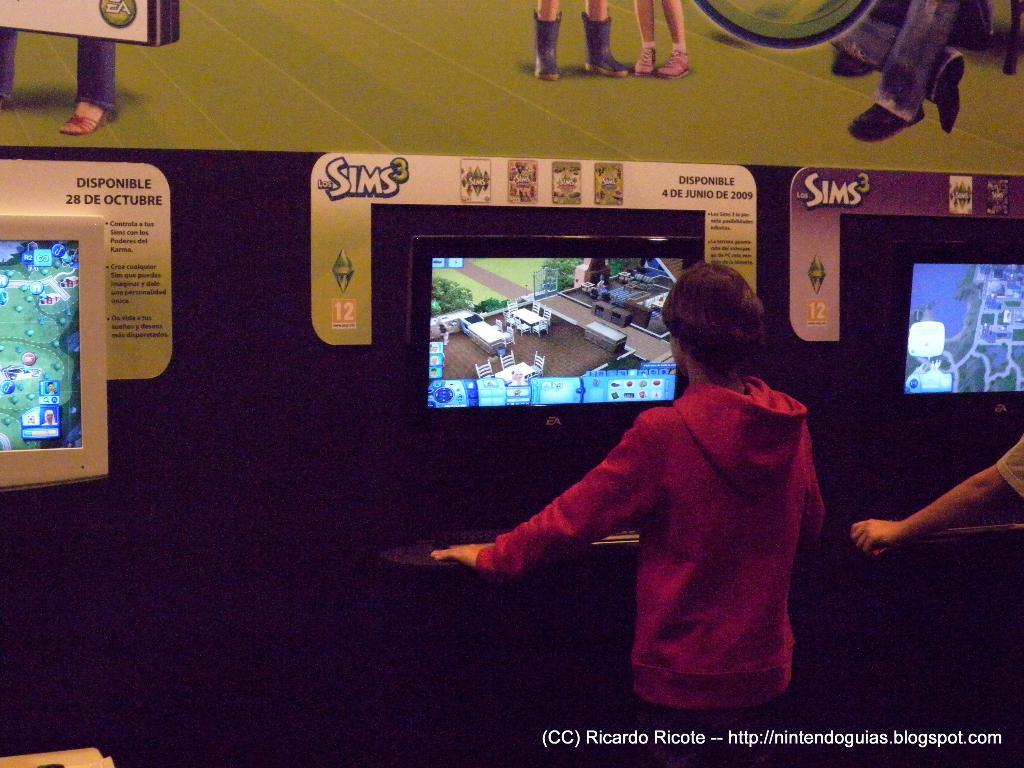Who is present in the image? There are people in the image. What are the people doing in the image? The people are standing in front of a screen. What activity are the people engaged in? The people are playing a game. How does the earthquake affect the people in the image? There is no earthquake present in the image; the people are playing a game in front of a screen. 